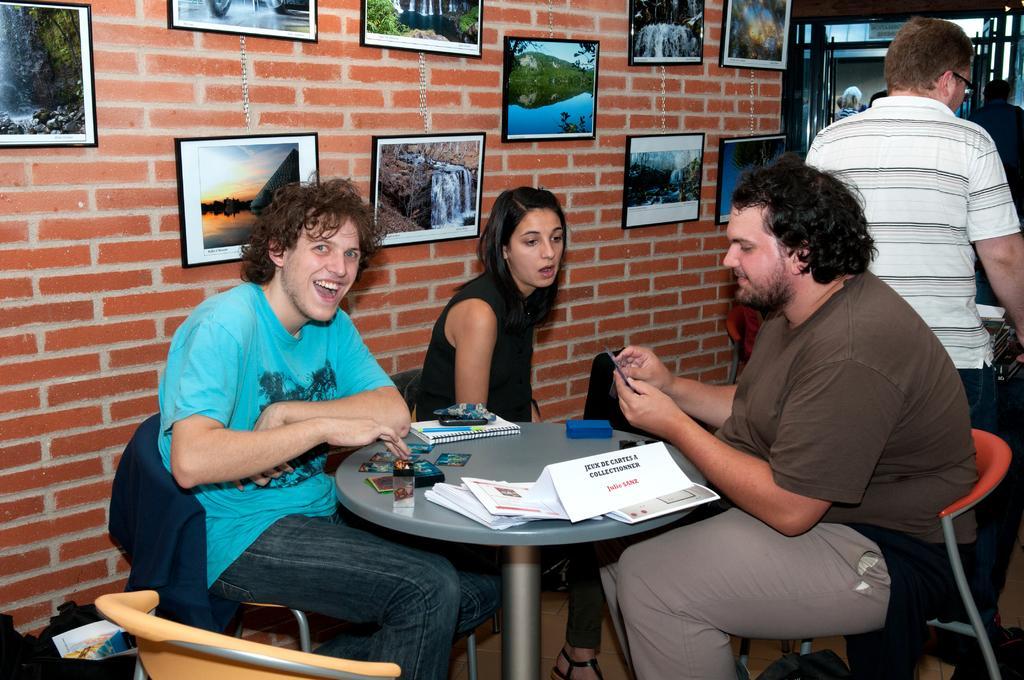Can you describe this image briefly? Here we can see a three people sitting on a chair and this two persons are having a smile on their face. This is a brick wall where all these photo frames are fixed. There is a person standing on the right side. 